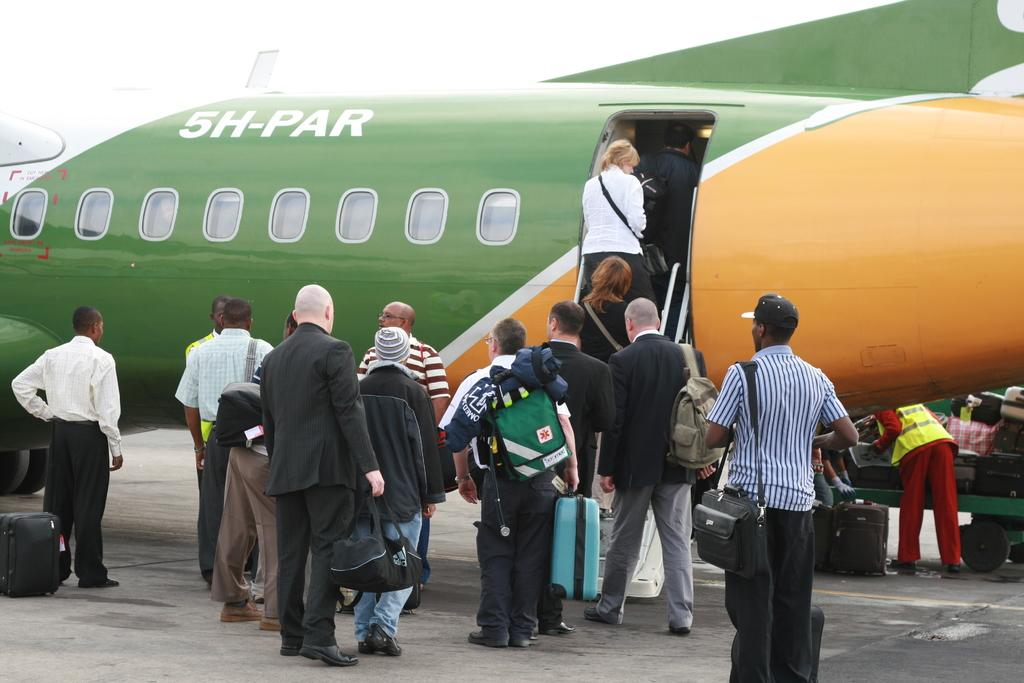<image>
Render a clear and concise summary of the photo. people boarding green and orange plane with 5H-PAR on the side 